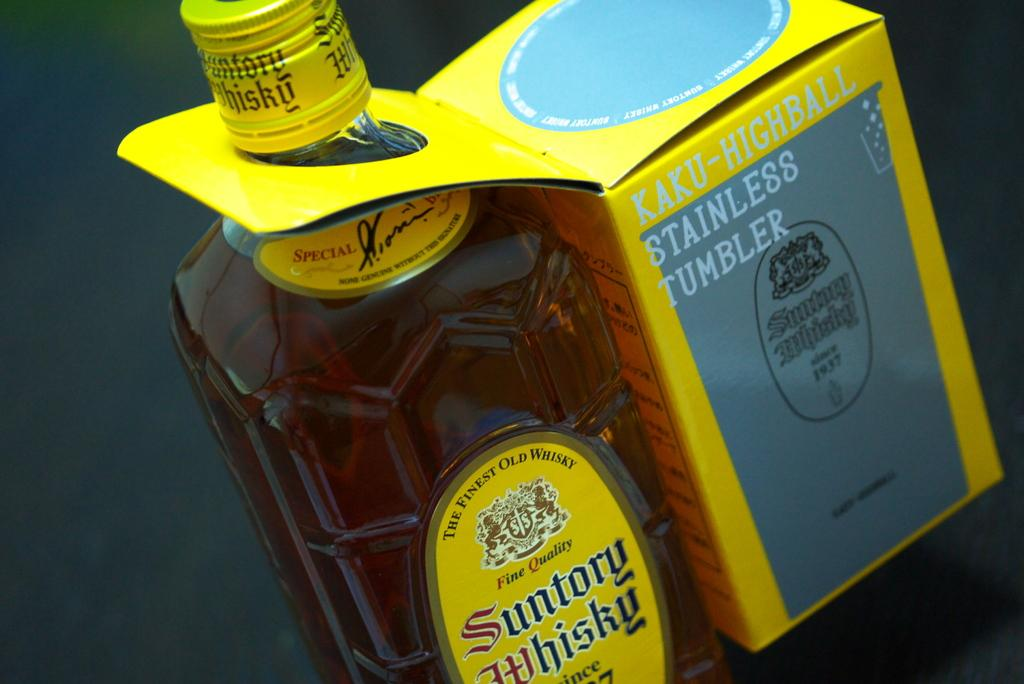<image>
Share a concise interpretation of the image provided. An unopened bottle of Suntory Whisky has a box containing a Kaku-Highball Stainless Tumbler attached. 